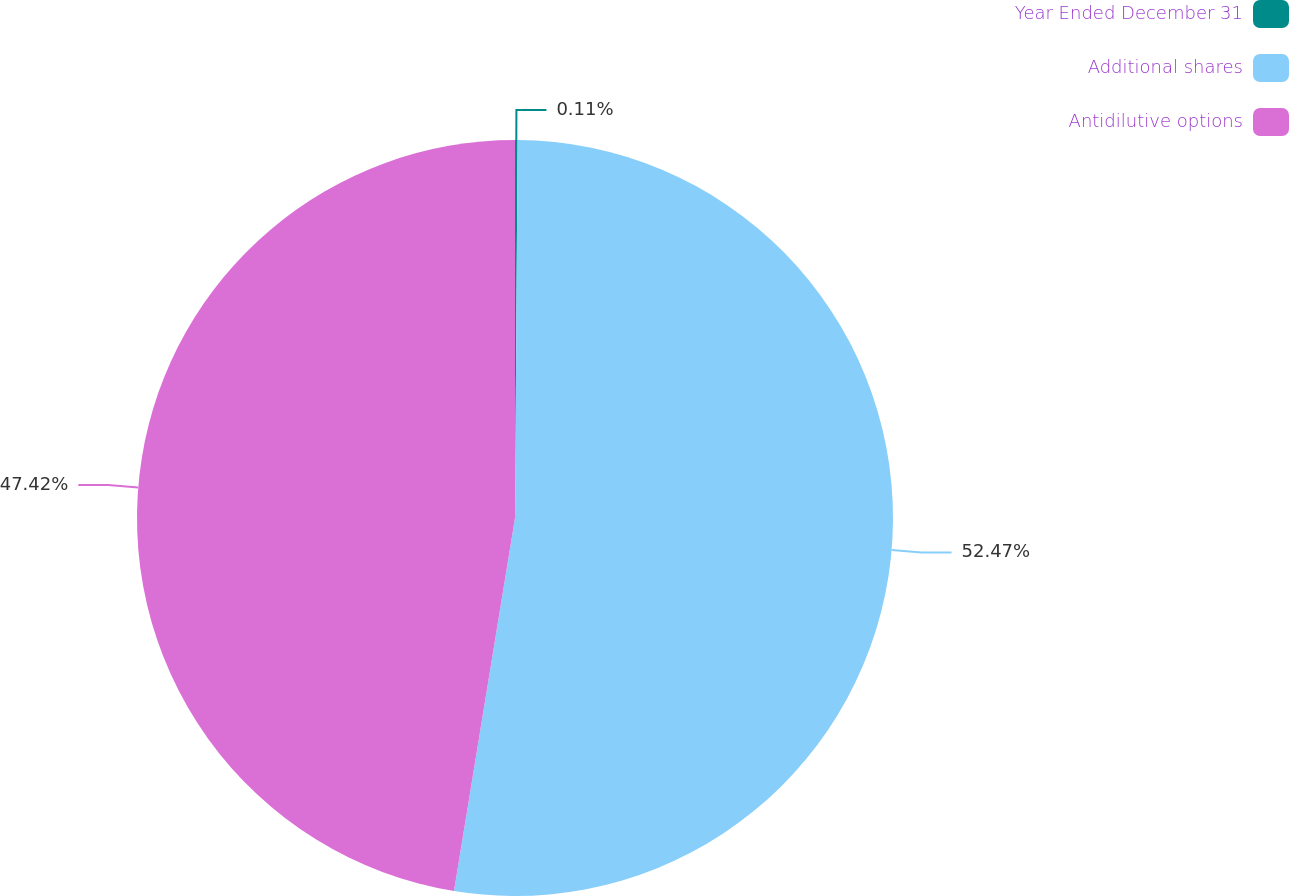<chart> <loc_0><loc_0><loc_500><loc_500><pie_chart><fcel>Year Ended December 31<fcel>Additional shares<fcel>Antidilutive options<nl><fcel>0.11%<fcel>52.47%<fcel>47.42%<nl></chart> 